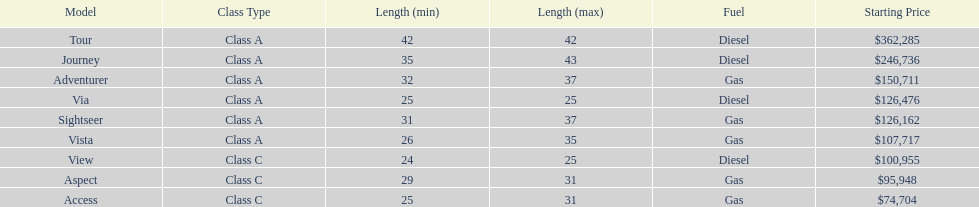Which model has the lowest started price? Access. 